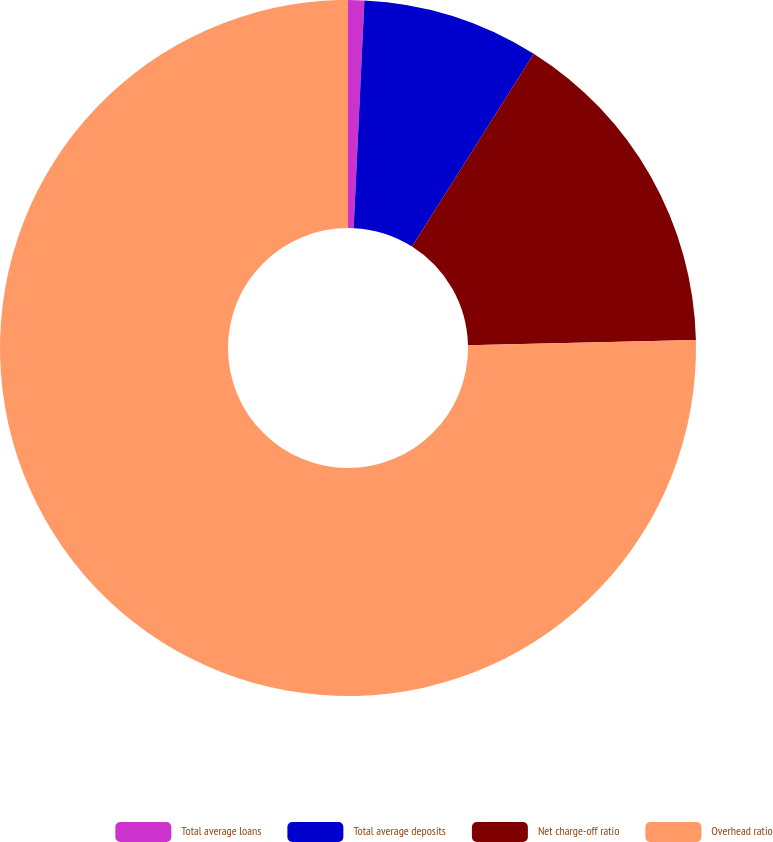Convert chart to OTSL. <chart><loc_0><loc_0><loc_500><loc_500><pie_chart><fcel>Total average loans<fcel>Total average deposits<fcel>Net charge-off ratio<fcel>Overhead ratio<nl><fcel>0.75%<fcel>8.21%<fcel>15.67%<fcel>75.36%<nl></chart> 